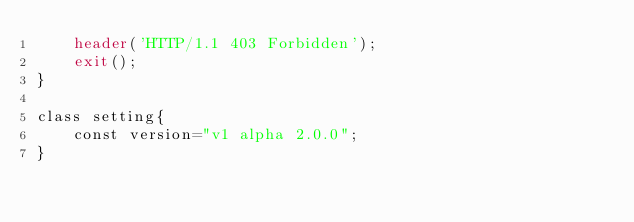Convert code to text. <code><loc_0><loc_0><loc_500><loc_500><_PHP_>    header('HTTP/1.1 403 Forbidden');
    exit();
}

class setting{
    const version="v1 alpha 2.0.0";
}</code> 